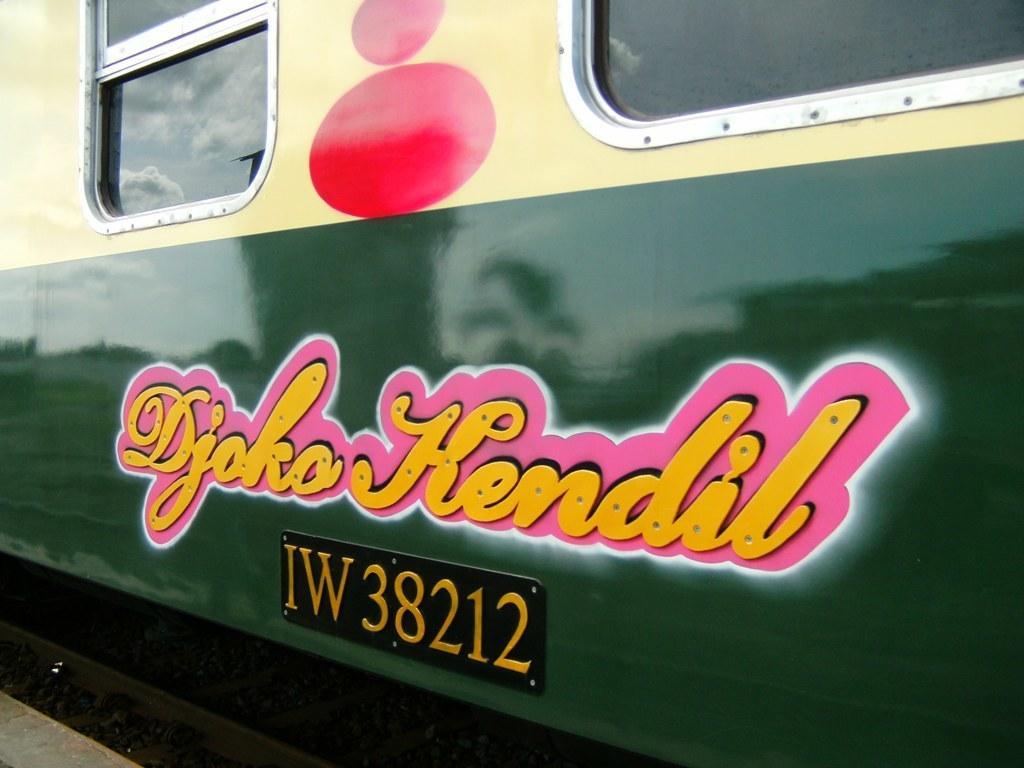Can you describe this image briefly? In this picture I can see a train in front and I see something is written on it. On the top of this picture I can see the windows. 